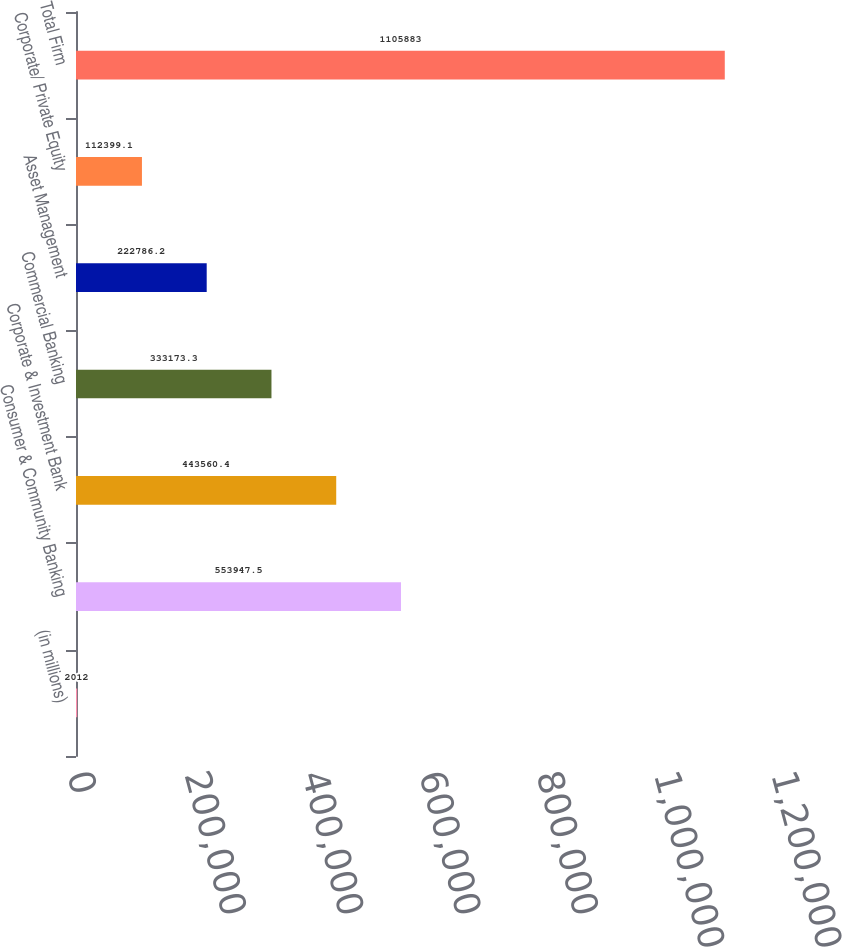Convert chart to OTSL. <chart><loc_0><loc_0><loc_500><loc_500><bar_chart><fcel>(in millions)<fcel>Consumer & Community Banking<fcel>Corporate & Investment Bank<fcel>Commercial Banking<fcel>Asset Management<fcel>Corporate/ Private Equity<fcel>Total Firm<nl><fcel>2012<fcel>553948<fcel>443560<fcel>333173<fcel>222786<fcel>112399<fcel>1.10588e+06<nl></chart> 